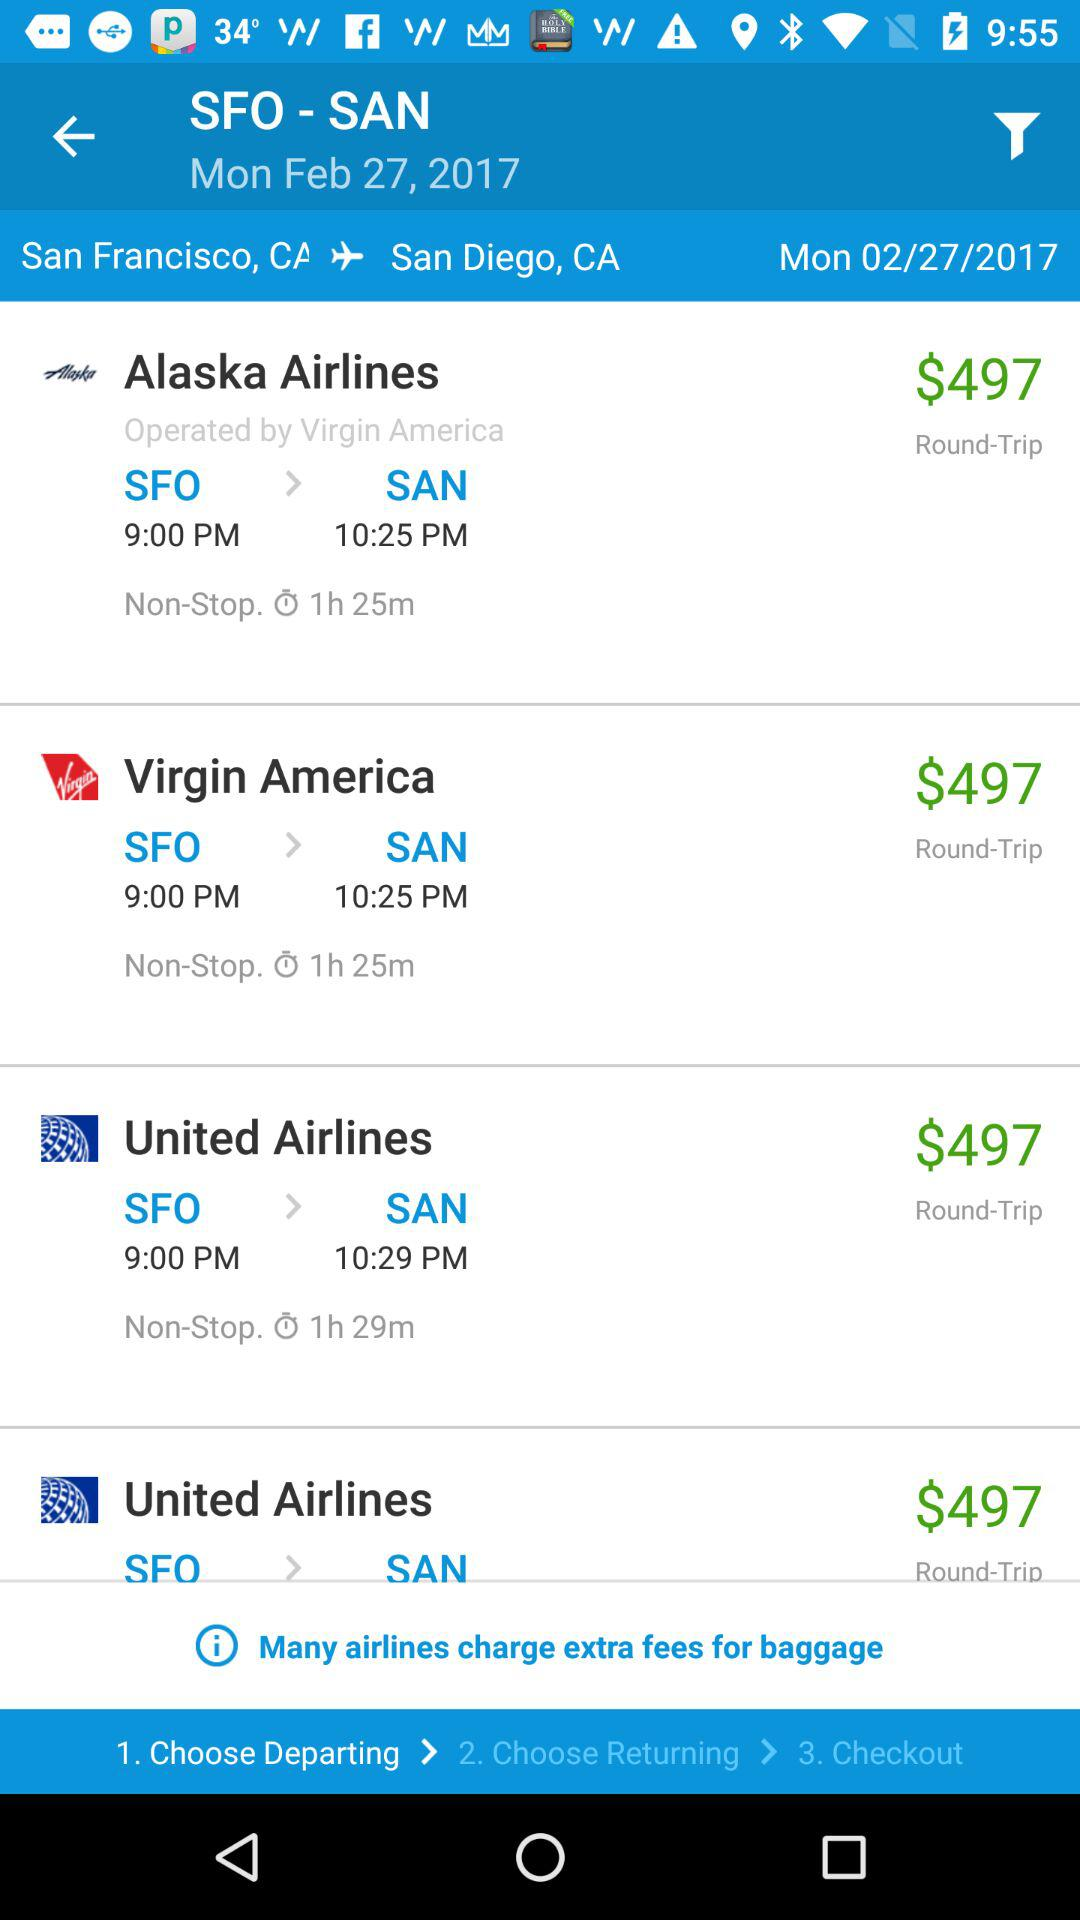What is the journey time of "Virgin" airlines? The journey time is 1 hour 25 minutes. 